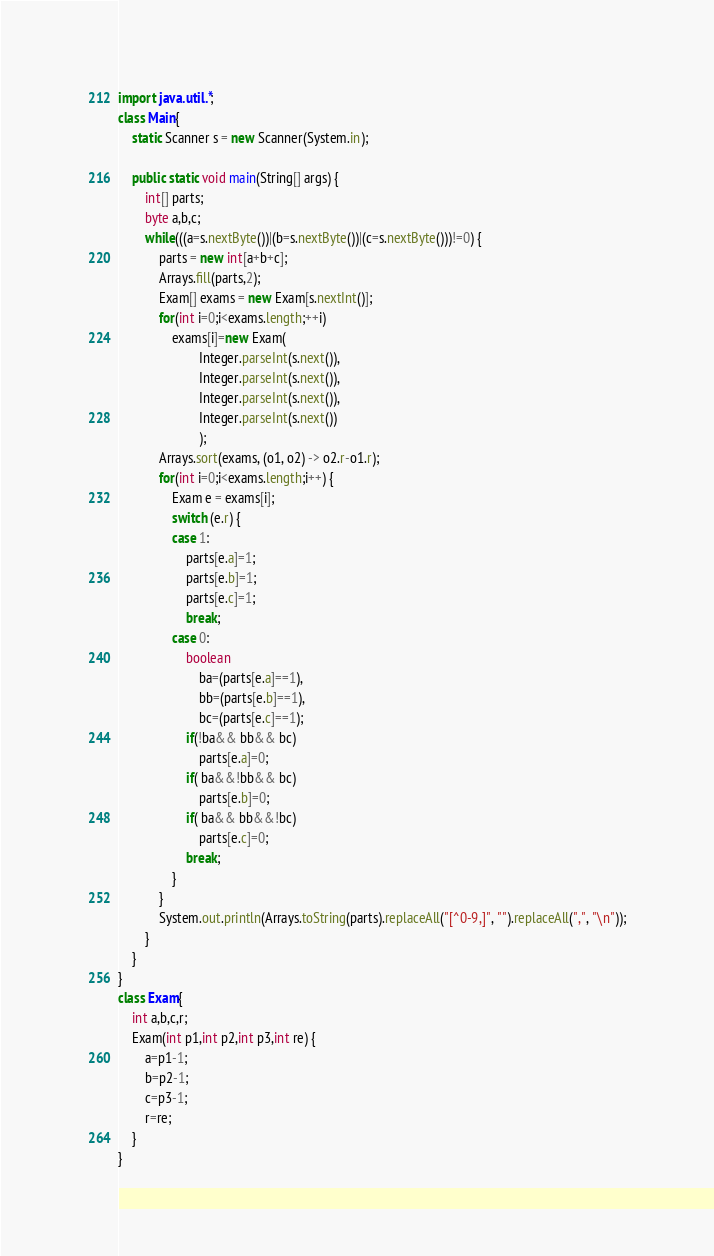<code> <loc_0><loc_0><loc_500><loc_500><_Java_>import java.util.*;
class Main{
	static Scanner s = new Scanner(System.in);

	public static void main(String[] args) {
		int[] parts;
		byte a,b,c;
		while(((a=s.nextByte())|(b=s.nextByte())|(c=s.nextByte()))!=0) {
			parts = new int[a+b+c];
			Arrays.fill(parts,2);
			Exam[] exams = new Exam[s.nextInt()];
			for(int i=0;i<exams.length;++i)
				exams[i]=new Exam(
						Integer.parseInt(s.next()),
						Integer.parseInt(s.next()),
						Integer.parseInt(s.next()),
						Integer.parseInt(s.next())
						);
			Arrays.sort(exams, (o1, o2) -> o2.r-o1.r);
			for(int i=0;i<exams.length;i++) {
				Exam e = exams[i];
				switch (e.r) {
				case 1:
					parts[e.a]=1;
					parts[e.b]=1;
					parts[e.c]=1;
					break;
				case 0:
					boolean
						ba=(parts[e.a]==1),
						bb=(parts[e.b]==1),
						bc=(parts[e.c]==1);
					if(!ba&& bb&& bc)
						parts[e.a]=0;
					if( ba&&!bb&& bc)
						parts[e.b]=0;
					if( ba&& bb&&!bc)
						parts[e.c]=0;
					break;
				}
			}
			System.out.println(Arrays.toString(parts).replaceAll("[^0-9,]", "").replaceAll(",", "\n"));
		}
	}
}
class Exam{
	int a,b,c,r;
	Exam(int p1,int p2,int p3,int re) {
		a=p1-1;
		b=p2-1;
		c=p3-1;
		r=re;
	}
}</code> 